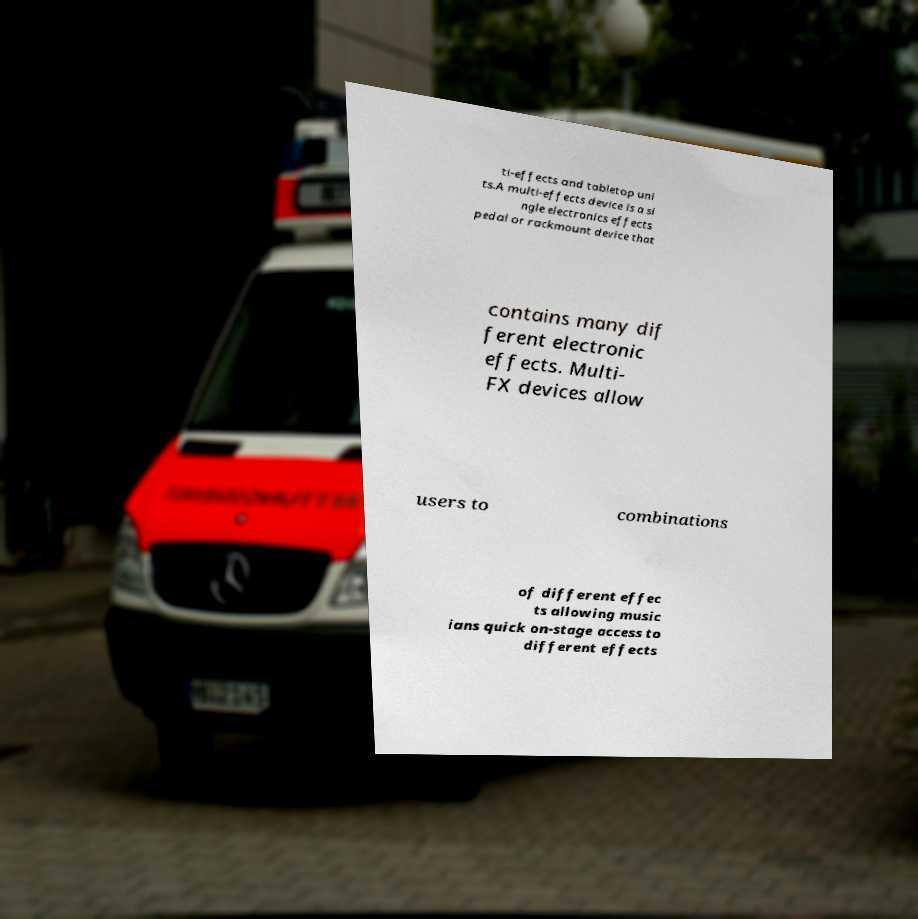I need the written content from this picture converted into text. Can you do that? ti-effects and tabletop uni ts.A multi-effects device is a si ngle electronics effects pedal or rackmount device that contains many dif ferent electronic effects. Multi- FX devices allow users to combinations of different effec ts allowing music ians quick on-stage access to different effects 